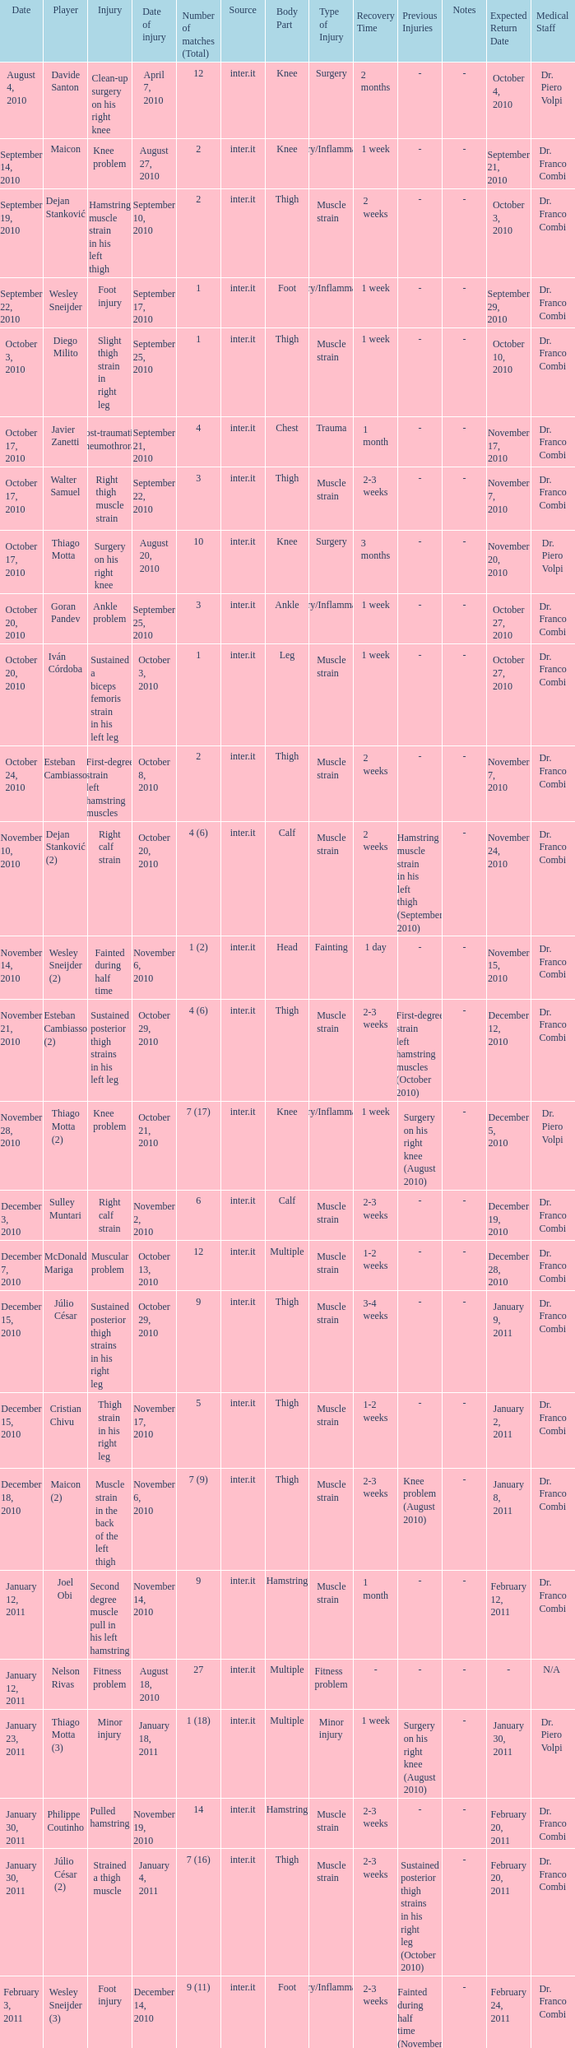What is the date of injury when the injury is sustained posterior thigh strains in his left leg? October 29, 2010. 